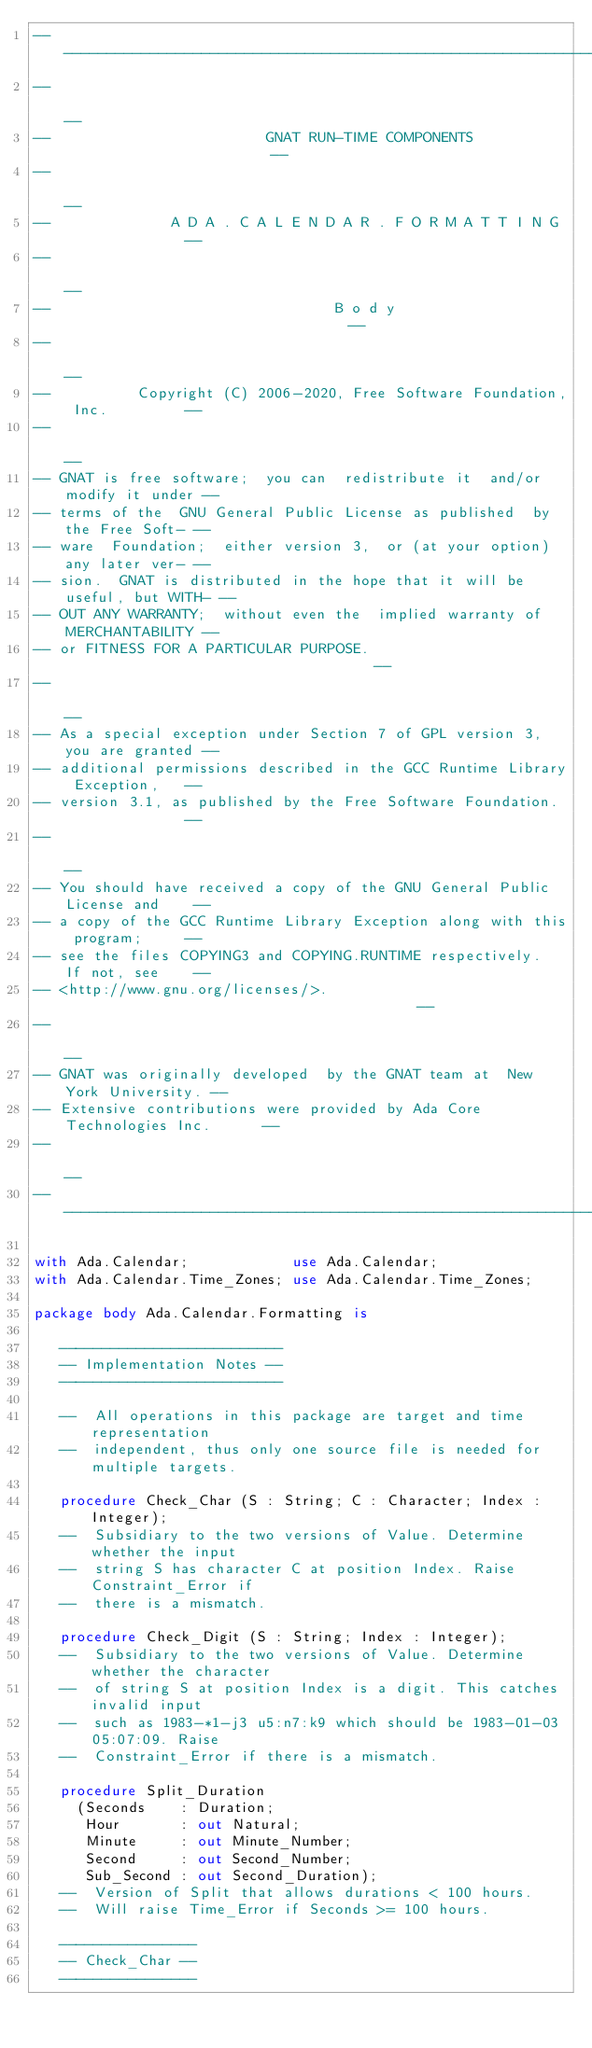<code> <loc_0><loc_0><loc_500><loc_500><_Ada_>------------------------------------------------------------------------------
--                                                                          --
--                         GNAT RUN-TIME COMPONENTS                         --
--                                                                          --
--              A D A . C A L E N D A R . F O R M A T T I N G               --
--                                                                          --
--                                 B o d y                                  --
--                                                                          --
--          Copyright (C) 2006-2020, Free Software Foundation, Inc.         --
--                                                                          --
-- GNAT is free software;  you can  redistribute it  and/or modify it under --
-- terms of the  GNU General Public License as published  by the Free Soft- --
-- ware  Foundation;  either version 3,  or (at your option) any later ver- --
-- sion.  GNAT is distributed in the hope that it will be useful, but WITH- --
-- OUT ANY WARRANTY;  without even the  implied warranty of MERCHANTABILITY --
-- or FITNESS FOR A PARTICULAR PURPOSE.                                     --
--                                                                          --
-- As a special exception under Section 7 of GPL version 3, you are granted --
-- additional permissions described in the GCC Runtime Library Exception,   --
-- version 3.1, as published by the Free Software Foundation.               --
--                                                                          --
-- You should have received a copy of the GNU General Public License and    --
-- a copy of the GCC Runtime Library Exception along with this program;     --
-- see the files COPYING3 and COPYING.RUNTIME respectively.  If not, see    --
-- <http://www.gnu.org/licenses/>.                                          --
--                                                                          --
-- GNAT was originally developed  by the GNAT team at  New York University. --
-- Extensive contributions were provided by Ada Core Technologies Inc.      --
--                                                                          --
------------------------------------------------------------------------------

with Ada.Calendar;            use Ada.Calendar;
with Ada.Calendar.Time_Zones; use Ada.Calendar.Time_Zones;

package body Ada.Calendar.Formatting is

   --------------------------
   -- Implementation Notes --
   --------------------------

   --  All operations in this package are target and time representation
   --  independent, thus only one source file is needed for multiple targets.

   procedure Check_Char (S : String; C : Character; Index : Integer);
   --  Subsidiary to the two versions of Value. Determine whether the input
   --  string S has character C at position Index. Raise Constraint_Error if
   --  there is a mismatch.

   procedure Check_Digit (S : String; Index : Integer);
   --  Subsidiary to the two versions of Value. Determine whether the character
   --  of string S at position Index is a digit. This catches invalid input
   --  such as 1983-*1-j3 u5:n7:k9 which should be 1983-01-03 05:07:09. Raise
   --  Constraint_Error if there is a mismatch.

   procedure Split_Duration
     (Seconds    : Duration;
      Hour       : out Natural;
      Minute     : out Minute_Number;
      Second     : out Second_Number;
      Sub_Second : out Second_Duration);
   --  Version of Split that allows durations < 100 hours.
   --  Will raise Time_Error if Seconds >= 100 hours.

   ----------------
   -- Check_Char --
   ----------------
</code> 